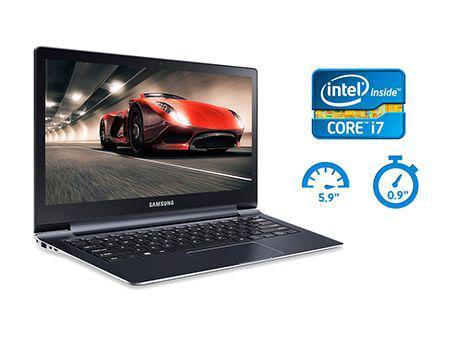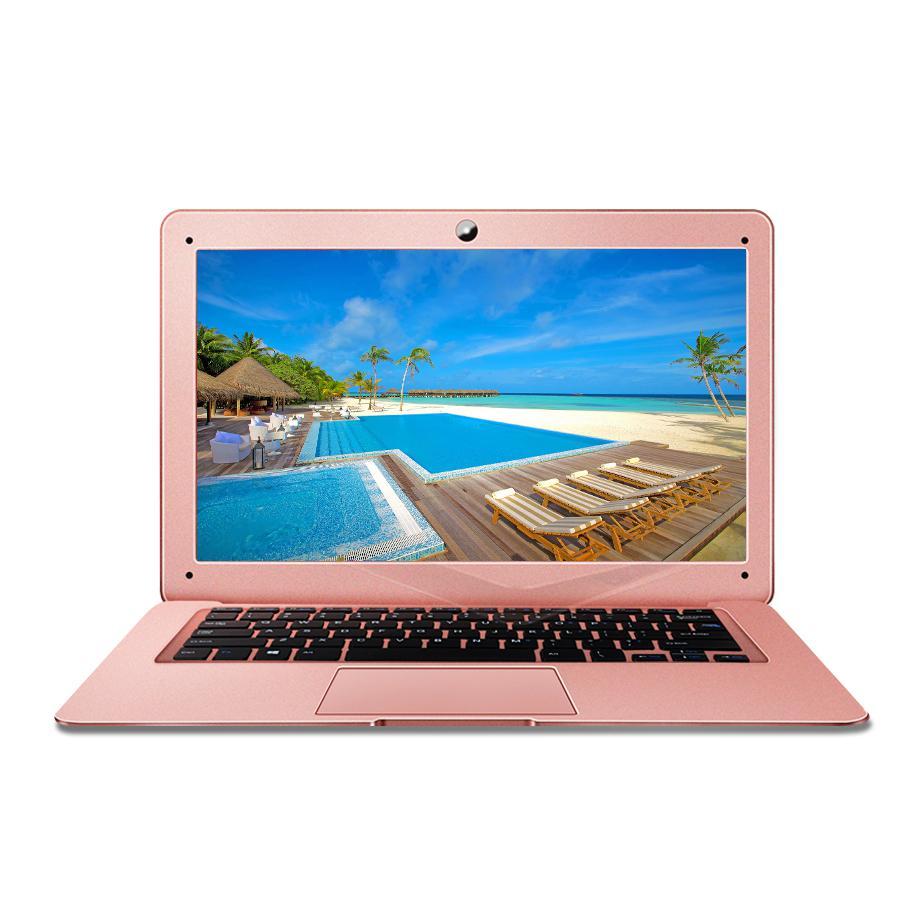The first image is the image on the left, the second image is the image on the right. Given the left and right images, does the statement "There is a black laptop to the left of a lighter colored laptop" hold true? Answer yes or no. Yes. The first image is the image on the left, the second image is the image on the right. Assess this claim about the two images: "One fully open laptop computer is black, and a second laptop is a different color.". Correct or not? Answer yes or no. Yes. 